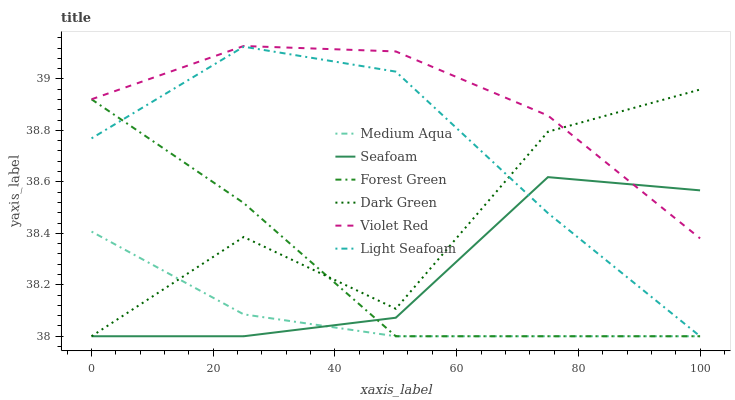Does Medium Aqua have the minimum area under the curve?
Answer yes or no. Yes. Does Violet Red have the maximum area under the curve?
Answer yes or no. Yes. Does Seafoam have the minimum area under the curve?
Answer yes or no. No. Does Seafoam have the maximum area under the curve?
Answer yes or no. No. Is Medium Aqua the smoothest?
Answer yes or no. Yes. Is Dark Green the roughest?
Answer yes or no. Yes. Is Seafoam the smoothest?
Answer yes or no. No. Is Seafoam the roughest?
Answer yes or no. No. Does Seafoam have the lowest value?
Answer yes or no. Yes. Does Violet Red have the highest value?
Answer yes or no. Yes. Does Seafoam have the highest value?
Answer yes or no. No. Is Light Seafoam less than Violet Red?
Answer yes or no. Yes. Is Violet Red greater than Light Seafoam?
Answer yes or no. Yes. Does Seafoam intersect Medium Aqua?
Answer yes or no. Yes. Is Seafoam less than Medium Aqua?
Answer yes or no. No. Is Seafoam greater than Medium Aqua?
Answer yes or no. No. Does Light Seafoam intersect Violet Red?
Answer yes or no. No. 